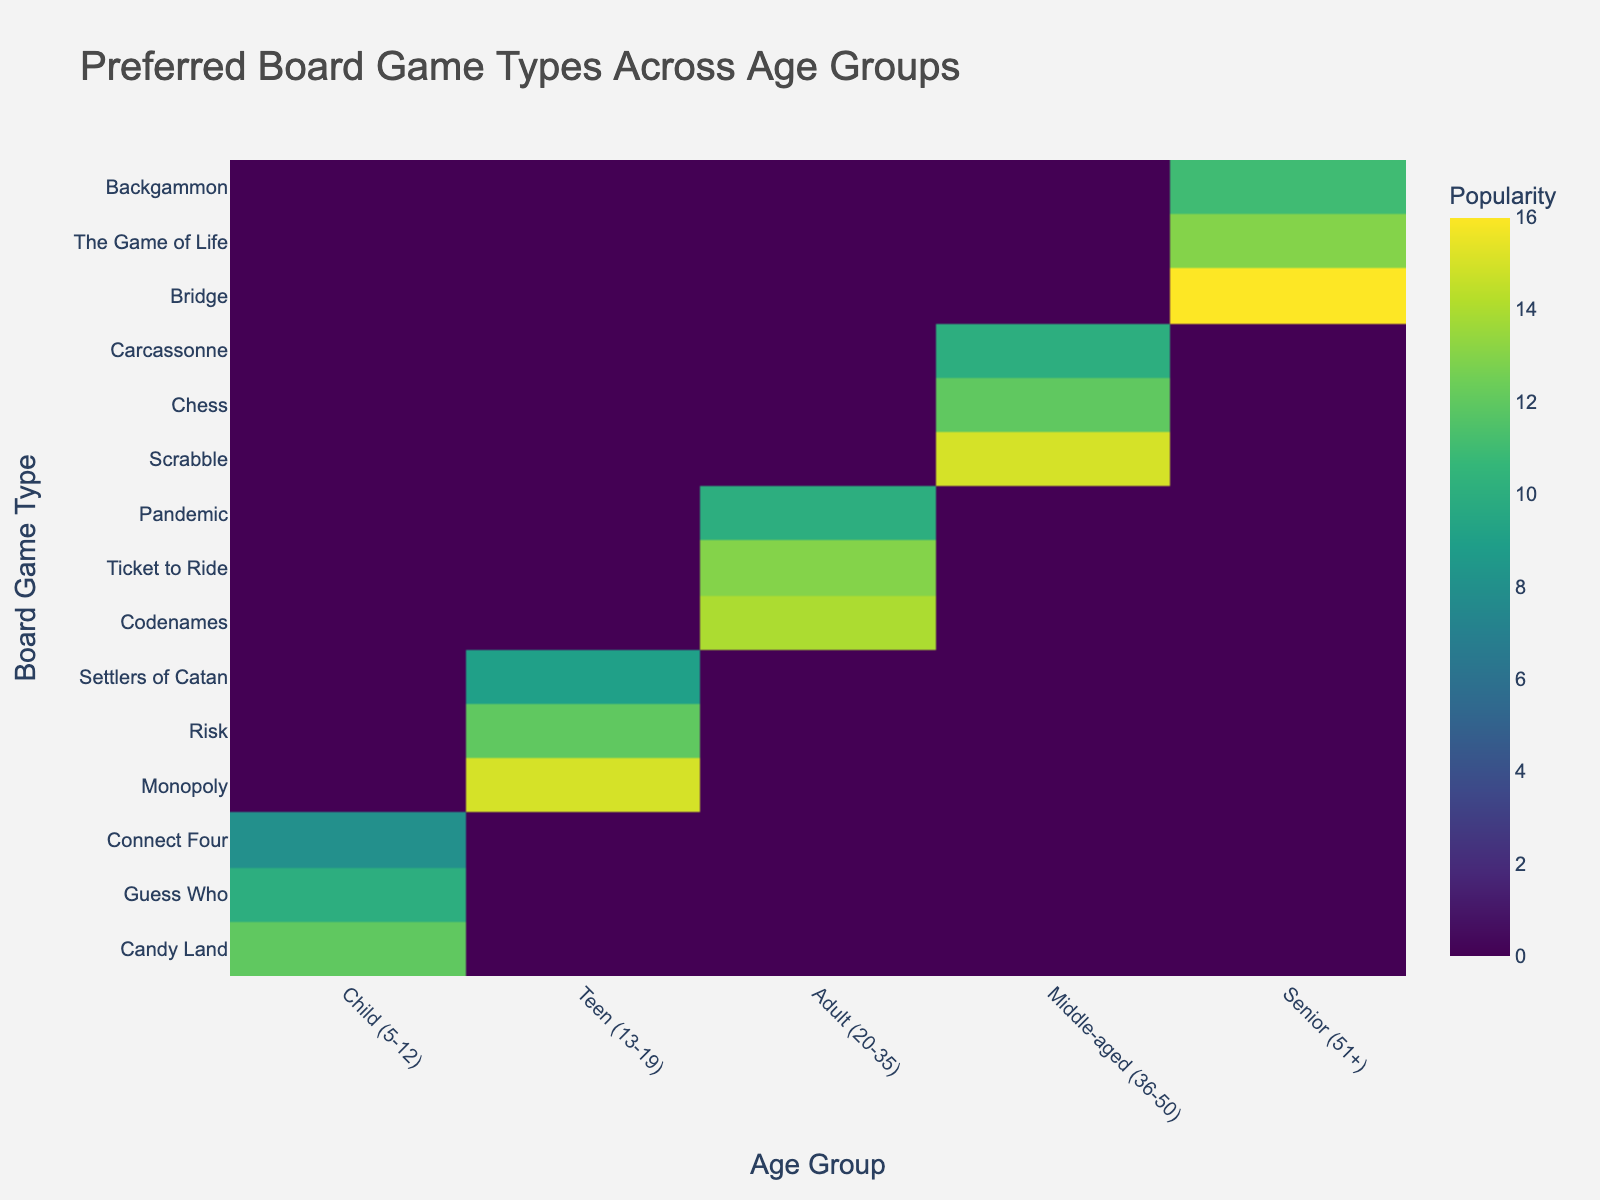What is the most popular board game among seniors (51+)? The density plot shows the popularity (frequency) of different board games across age groups. The board game with the highest frequency value in the "Senior (51+)" category is "Bridge" with a frequency of 16.
Answer: Bridge Which board game is more popular among teens (13-19), Risk or Settlers of Catan? By looking at the density plot for the "Teen (13-19)" age group, we can compare the popularity of "Risk" and "Settlers of Catan". "Risk" has a frequency of 12 while "Settlers of Catan" has a frequency of 9. Therefore, "Risk" is more popular.
Answer: Risk What is the total frequency of board games played by children (5-12)? To find the total frequency, sum the frequencies of all the board games in the "Child (5-12)" age group: Candy Land (12), Guess Who (10), and Connect Four (8). 12 + 10 + 8 = 30.
Answer: 30 Which age group prefers Scrabble the most? By examining the density plot, we identify which age group has the highest frequency for Scrabble. The "Middle-aged (36-50)" group has a frequency of 15 for Scrabble, which is the highest.
Answer: Middle-aged (36-50) How does the popularity of Codenames among adults (20-35) compare to that of Chess among middle-aged individuals (36-50)? By comparing the frequency values of Codenames in the adult age group and Chess in the middle-aged group in the plot, we see Codenames has a frequency of 14 and Chess has a frequency of 12. Thus, Codenames is more popular.
Answer: Codenames What is the average popularity of board games in the "Senior (51+)" age group? Calculate the average by summing the frequencies of all board games for the senior age group and dividing by the number of games: (Bridge (16) + The Game of Life (13) + Backgammon (11)) / 3. (16 + 13 + 11) / 3 = 40 / 3 ≈ 13.33.
Answer: 13.33 Which board game in the "Adult (20-35)" group is least popular? By observing the frequency values in the adult age group, the game with the lowest frequency is "Pandemic" with a frequency of 10.
Answer: Pandemic 